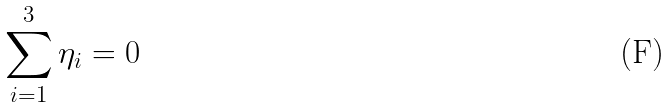Convert formula to latex. <formula><loc_0><loc_0><loc_500><loc_500>\sum _ { i = 1 } ^ { 3 } \eta _ { i } = 0</formula> 